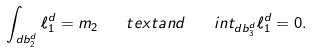Convert formula to latex. <formula><loc_0><loc_0><loc_500><loc_500>\int _ { d b _ { 2 } ^ { d } } \ell _ { 1 } ^ { d } = m _ { 2 } \quad t e x t { a n d } \ \ \ i n t _ { d b _ { 3 } ^ { d } } \ell _ { 1 } ^ { d } = 0 .</formula> 